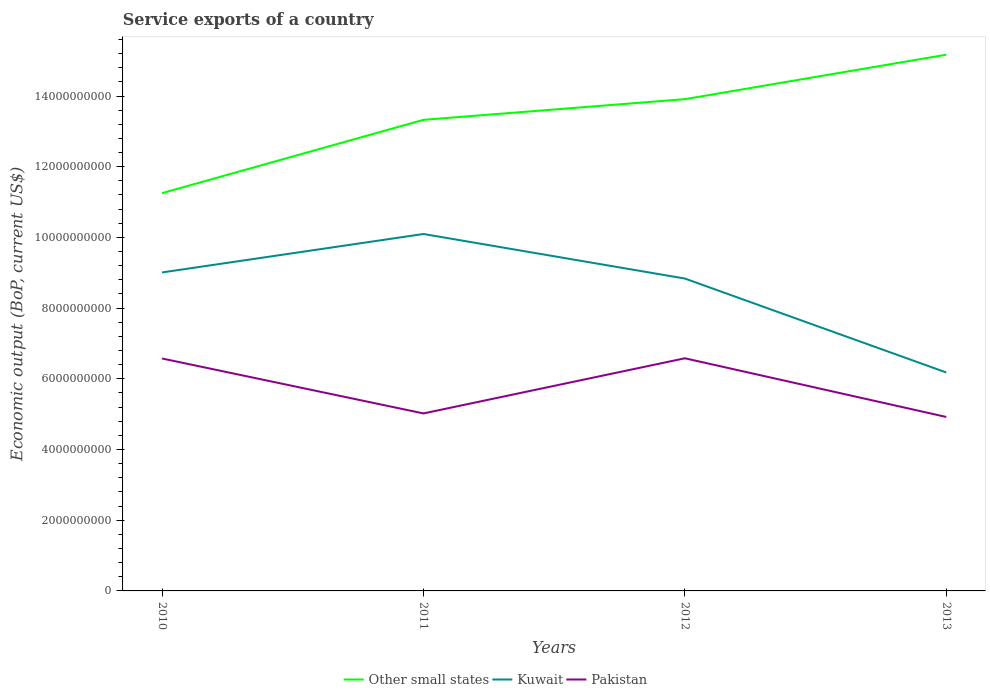How many different coloured lines are there?
Your answer should be compact. 3. Across all years, what is the maximum service exports in Pakistan?
Your answer should be compact. 4.92e+09. What is the total service exports in Pakistan in the graph?
Your answer should be very brief. 1.55e+09. What is the difference between the highest and the second highest service exports in Pakistan?
Provide a succinct answer. 1.66e+09. What is the difference between the highest and the lowest service exports in Other small states?
Provide a short and direct response. 2. What is the difference between two consecutive major ticks on the Y-axis?
Give a very brief answer. 2.00e+09. Does the graph contain grids?
Ensure brevity in your answer.  No. How are the legend labels stacked?
Your response must be concise. Horizontal. What is the title of the graph?
Your answer should be compact. Service exports of a country. Does "Iraq" appear as one of the legend labels in the graph?
Offer a very short reply. No. What is the label or title of the X-axis?
Offer a terse response. Years. What is the label or title of the Y-axis?
Your answer should be compact. Economic output (BoP, current US$). What is the Economic output (BoP, current US$) in Other small states in 2010?
Offer a very short reply. 1.13e+1. What is the Economic output (BoP, current US$) of Kuwait in 2010?
Keep it short and to the point. 9.01e+09. What is the Economic output (BoP, current US$) of Pakistan in 2010?
Provide a short and direct response. 6.58e+09. What is the Economic output (BoP, current US$) of Other small states in 2011?
Offer a terse response. 1.33e+1. What is the Economic output (BoP, current US$) in Kuwait in 2011?
Ensure brevity in your answer.  1.01e+1. What is the Economic output (BoP, current US$) in Pakistan in 2011?
Your response must be concise. 5.02e+09. What is the Economic output (BoP, current US$) of Other small states in 2012?
Provide a short and direct response. 1.39e+1. What is the Economic output (BoP, current US$) of Kuwait in 2012?
Your answer should be compact. 8.84e+09. What is the Economic output (BoP, current US$) in Pakistan in 2012?
Ensure brevity in your answer.  6.58e+09. What is the Economic output (BoP, current US$) in Other small states in 2013?
Provide a succinct answer. 1.52e+1. What is the Economic output (BoP, current US$) of Kuwait in 2013?
Give a very brief answer. 6.18e+09. What is the Economic output (BoP, current US$) in Pakistan in 2013?
Offer a very short reply. 4.92e+09. Across all years, what is the maximum Economic output (BoP, current US$) of Other small states?
Your answer should be compact. 1.52e+1. Across all years, what is the maximum Economic output (BoP, current US$) in Kuwait?
Keep it short and to the point. 1.01e+1. Across all years, what is the maximum Economic output (BoP, current US$) in Pakistan?
Provide a succinct answer. 6.58e+09. Across all years, what is the minimum Economic output (BoP, current US$) of Other small states?
Keep it short and to the point. 1.13e+1. Across all years, what is the minimum Economic output (BoP, current US$) in Kuwait?
Provide a succinct answer. 6.18e+09. Across all years, what is the minimum Economic output (BoP, current US$) in Pakistan?
Your answer should be very brief. 4.92e+09. What is the total Economic output (BoP, current US$) of Other small states in the graph?
Offer a terse response. 5.37e+1. What is the total Economic output (BoP, current US$) in Kuwait in the graph?
Provide a short and direct response. 3.41e+1. What is the total Economic output (BoP, current US$) in Pakistan in the graph?
Your answer should be very brief. 2.31e+1. What is the difference between the Economic output (BoP, current US$) of Other small states in 2010 and that in 2011?
Provide a succinct answer. -2.07e+09. What is the difference between the Economic output (BoP, current US$) in Kuwait in 2010 and that in 2011?
Provide a succinct answer. -1.09e+09. What is the difference between the Economic output (BoP, current US$) of Pakistan in 2010 and that in 2011?
Keep it short and to the point. 1.55e+09. What is the difference between the Economic output (BoP, current US$) in Other small states in 2010 and that in 2012?
Offer a terse response. -2.66e+09. What is the difference between the Economic output (BoP, current US$) of Kuwait in 2010 and that in 2012?
Offer a terse response. 1.73e+08. What is the difference between the Economic output (BoP, current US$) in Pakistan in 2010 and that in 2012?
Keep it short and to the point. -6.20e+06. What is the difference between the Economic output (BoP, current US$) of Other small states in 2010 and that in 2013?
Provide a short and direct response. -3.92e+09. What is the difference between the Economic output (BoP, current US$) of Kuwait in 2010 and that in 2013?
Provide a succinct answer. 2.83e+09. What is the difference between the Economic output (BoP, current US$) of Pakistan in 2010 and that in 2013?
Ensure brevity in your answer.  1.65e+09. What is the difference between the Economic output (BoP, current US$) in Other small states in 2011 and that in 2012?
Provide a short and direct response. -5.85e+08. What is the difference between the Economic output (BoP, current US$) in Kuwait in 2011 and that in 2012?
Provide a succinct answer. 1.26e+09. What is the difference between the Economic output (BoP, current US$) of Pakistan in 2011 and that in 2012?
Offer a terse response. -1.56e+09. What is the difference between the Economic output (BoP, current US$) of Other small states in 2011 and that in 2013?
Offer a terse response. -1.84e+09. What is the difference between the Economic output (BoP, current US$) in Kuwait in 2011 and that in 2013?
Ensure brevity in your answer.  3.92e+09. What is the difference between the Economic output (BoP, current US$) in Pakistan in 2011 and that in 2013?
Your answer should be very brief. 1.00e+08. What is the difference between the Economic output (BoP, current US$) in Other small states in 2012 and that in 2013?
Ensure brevity in your answer.  -1.26e+09. What is the difference between the Economic output (BoP, current US$) of Kuwait in 2012 and that in 2013?
Your answer should be compact. 2.66e+09. What is the difference between the Economic output (BoP, current US$) of Pakistan in 2012 and that in 2013?
Give a very brief answer. 1.66e+09. What is the difference between the Economic output (BoP, current US$) in Other small states in 2010 and the Economic output (BoP, current US$) in Kuwait in 2011?
Offer a terse response. 1.16e+09. What is the difference between the Economic output (BoP, current US$) of Other small states in 2010 and the Economic output (BoP, current US$) of Pakistan in 2011?
Ensure brevity in your answer.  6.23e+09. What is the difference between the Economic output (BoP, current US$) in Kuwait in 2010 and the Economic output (BoP, current US$) in Pakistan in 2011?
Provide a short and direct response. 3.99e+09. What is the difference between the Economic output (BoP, current US$) of Other small states in 2010 and the Economic output (BoP, current US$) of Kuwait in 2012?
Your response must be concise. 2.42e+09. What is the difference between the Economic output (BoP, current US$) of Other small states in 2010 and the Economic output (BoP, current US$) of Pakistan in 2012?
Your answer should be very brief. 4.67e+09. What is the difference between the Economic output (BoP, current US$) in Kuwait in 2010 and the Economic output (BoP, current US$) in Pakistan in 2012?
Provide a succinct answer. 2.43e+09. What is the difference between the Economic output (BoP, current US$) of Other small states in 2010 and the Economic output (BoP, current US$) of Kuwait in 2013?
Keep it short and to the point. 5.07e+09. What is the difference between the Economic output (BoP, current US$) in Other small states in 2010 and the Economic output (BoP, current US$) in Pakistan in 2013?
Your answer should be very brief. 6.33e+09. What is the difference between the Economic output (BoP, current US$) of Kuwait in 2010 and the Economic output (BoP, current US$) of Pakistan in 2013?
Your answer should be very brief. 4.09e+09. What is the difference between the Economic output (BoP, current US$) in Other small states in 2011 and the Economic output (BoP, current US$) in Kuwait in 2012?
Provide a short and direct response. 4.49e+09. What is the difference between the Economic output (BoP, current US$) of Other small states in 2011 and the Economic output (BoP, current US$) of Pakistan in 2012?
Your answer should be compact. 6.75e+09. What is the difference between the Economic output (BoP, current US$) in Kuwait in 2011 and the Economic output (BoP, current US$) in Pakistan in 2012?
Provide a succinct answer. 3.52e+09. What is the difference between the Economic output (BoP, current US$) in Other small states in 2011 and the Economic output (BoP, current US$) in Kuwait in 2013?
Keep it short and to the point. 7.15e+09. What is the difference between the Economic output (BoP, current US$) of Other small states in 2011 and the Economic output (BoP, current US$) of Pakistan in 2013?
Keep it short and to the point. 8.41e+09. What is the difference between the Economic output (BoP, current US$) in Kuwait in 2011 and the Economic output (BoP, current US$) in Pakistan in 2013?
Keep it short and to the point. 5.18e+09. What is the difference between the Economic output (BoP, current US$) in Other small states in 2012 and the Economic output (BoP, current US$) in Kuwait in 2013?
Give a very brief answer. 7.73e+09. What is the difference between the Economic output (BoP, current US$) in Other small states in 2012 and the Economic output (BoP, current US$) in Pakistan in 2013?
Provide a succinct answer. 8.99e+09. What is the difference between the Economic output (BoP, current US$) in Kuwait in 2012 and the Economic output (BoP, current US$) in Pakistan in 2013?
Give a very brief answer. 3.92e+09. What is the average Economic output (BoP, current US$) in Other small states per year?
Ensure brevity in your answer.  1.34e+1. What is the average Economic output (BoP, current US$) of Kuwait per year?
Your answer should be compact. 8.53e+09. What is the average Economic output (BoP, current US$) of Pakistan per year?
Provide a succinct answer. 5.77e+09. In the year 2010, what is the difference between the Economic output (BoP, current US$) of Other small states and Economic output (BoP, current US$) of Kuwait?
Your response must be concise. 2.24e+09. In the year 2010, what is the difference between the Economic output (BoP, current US$) of Other small states and Economic output (BoP, current US$) of Pakistan?
Ensure brevity in your answer.  4.68e+09. In the year 2010, what is the difference between the Economic output (BoP, current US$) of Kuwait and Economic output (BoP, current US$) of Pakistan?
Your answer should be compact. 2.43e+09. In the year 2011, what is the difference between the Economic output (BoP, current US$) in Other small states and Economic output (BoP, current US$) in Kuwait?
Give a very brief answer. 3.23e+09. In the year 2011, what is the difference between the Economic output (BoP, current US$) of Other small states and Economic output (BoP, current US$) of Pakistan?
Give a very brief answer. 8.31e+09. In the year 2011, what is the difference between the Economic output (BoP, current US$) in Kuwait and Economic output (BoP, current US$) in Pakistan?
Your answer should be compact. 5.08e+09. In the year 2012, what is the difference between the Economic output (BoP, current US$) in Other small states and Economic output (BoP, current US$) in Kuwait?
Keep it short and to the point. 5.07e+09. In the year 2012, what is the difference between the Economic output (BoP, current US$) in Other small states and Economic output (BoP, current US$) in Pakistan?
Ensure brevity in your answer.  7.33e+09. In the year 2012, what is the difference between the Economic output (BoP, current US$) of Kuwait and Economic output (BoP, current US$) of Pakistan?
Provide a short and direct response. 2.26e+09. In the year 2013, what is the difference between the Economic output (BoP, current US$) of Other small states and Economic output (BoP, current US$) of Kuwait?
Make the answer very short. 8.99e+09. In the year 2013, what is the difference between the Economic output (BoP, current US$) in Other small states and Economic output (BoP, current US$) in Pakistan?
Your answer should be compact. 1.02e+1. In the year 2013, what is the difference between the Economic output (BoP, current US$) in Kuwait and Economic output (BoP, current US$) in Pakistan?
Make the answer very short. 1.26e+09. What is the ratio of the Economic output (BoP, current US$) of Other small states in 2010 to that in 2011?
Your response must be concise. 0.84. What is the ratio of the Economic output (BoP, current US$) in Kuwait in 2010 to that in 2011?
Ensure brevity in your answer.  0.89. What is the ratio of the Economic output (BoP, current US$) of Pakistan in 2010 to that in 2011?
Make the answer very short. 1.31. What is the ratio of the Economic output (BoP, current US$) of Other small states in 2010 to that in 2012?
Offer a terse response. 0.81. What is the ratio of the Economic output (BoP, current US$) of Kuwait in 2010 to that in 2012?
Offer a terse response. 1.02. What is the ratio of the Economic output (BoP, current US$) in Other small states in 2010 to that in 2013?
Offer a terse response. 0.74. What is the ratio of the Economic output (BoP, current US$) in Kuwait in 2010 to that in 2013?
Your response must be concise. 1.46. What is the ratio of the Economic output (BoP, current US$) in Pakistan in 2010 to that in 2013?
Your answer should be compact. 1.34. What is the ratio of the Economic output (BoP, current US$) in Other small states in 2011 to that in 2012?
Keep it short and to the point. 0.96. What is the ratio of the Economic output (BoP, current US$) in Kuwait in 2011 to that in 2012?
Give a very brief answer. 1.14. What is the ratio of the Economic output (BoP, current US$) in Pakistan in 2011 to that in 2012?
Your answer should be very brief. 0.76. What is the ratio of the Economic output (BoP, current US$) of Other small states in 2011 to that in 2013?
Provide a short and direct response. 0.88. What is the ratio of the Economic output (BoP, current US$) in Kuwait in 2011 to that in 2013?
Provide a succinct answer. 1.63. What is the ratio of the Economic output (BoP, current US$) of Pakistan in 2011 to that in 2013?
Ensure brevity in your answer.  1.02. What is the ratio of the Economic output (BoP, current US$) in Other small states in 2012 to that in 2013?
Make the answer very short. 0.92. What is the ratio of the Economic output (BoP, current US$) of Kuwait in 2012 to that in 2013?
Your answer should be very brief. 1.43. What is the ratio of the Economic output (BoP, current US$) of Pakistan in 2012 to that in 2013?
Your answer should be compact. 1.34. What is the difference between the highest and the second highest Economic output (BoP, current US$) of Other small states?
Keep it short and to the point. 1.26e+09. What is the difference between the highest and the second highest Economic output (BoP, current US$) in Kuwait?
Ensure brevity in your answer.  1.09e+09. What is the difference between the highest and the second highest Economic output (BoP, current US$) of Pakistan?
Offer a terse response. 6.20e+06. What is the difference between the highest and the lowest Economic output (BoP, current US$) in Other small states?
Your answer should be compact. 3.92e+09. What is the difference between the highest and the lowest Economic output (BoP, current US$) in Kuwait?
Offer a very short reply. 3.92e+09. What is the difference between the highest and the lowest Economic output (BoP, current US$) of Pakistan?
Offer a very short reply. 1.66e+09. 